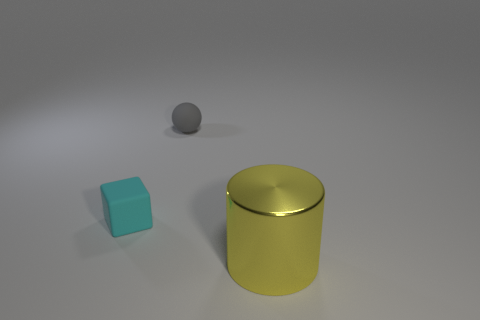Add 2 green metal things. How many objects exist? 5 Subtract all cylinders. How many objects are left? 2 Add 2 tiny gray spheres. How many tiny gray spheres exist? 3 Subtract 0 yellow balls. How many objects are left? 3 Subtract all cyan cubes. Subtract all small red rubber blocks. How many objects are left? 2 Add 2 small cyan rubber objects. How many small cyan rubber objects are left? 3 